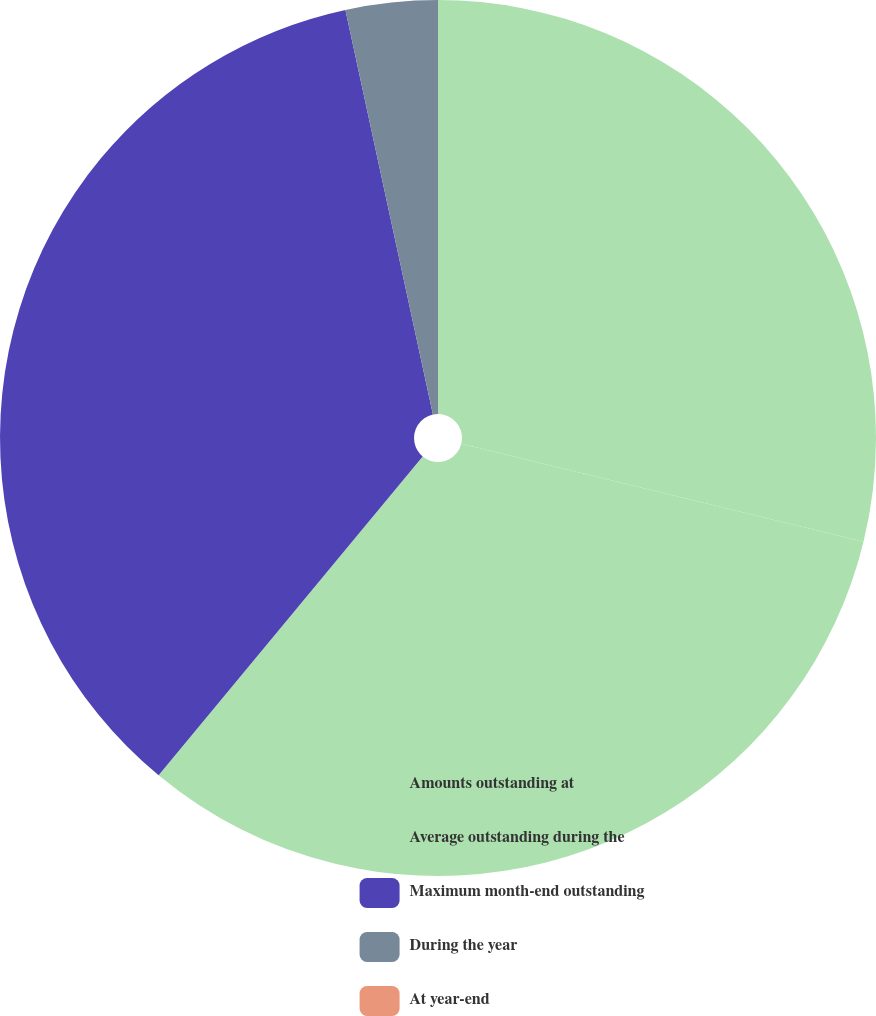Convert chart to OTSL. <chart><loc_0><loc_0><loc_500><loc_500><pie_chart><fcel>Amounts outstanding at<fcel>Average outstanding during the<fcel>Maximum month-end outstanding<fcel>During the year<fcel>At year-end<nl><fcel>28.81%<fcel>32.2%<fcel>35.6%<fcel>3.39%<fcel>0.0%<nl></chart> 